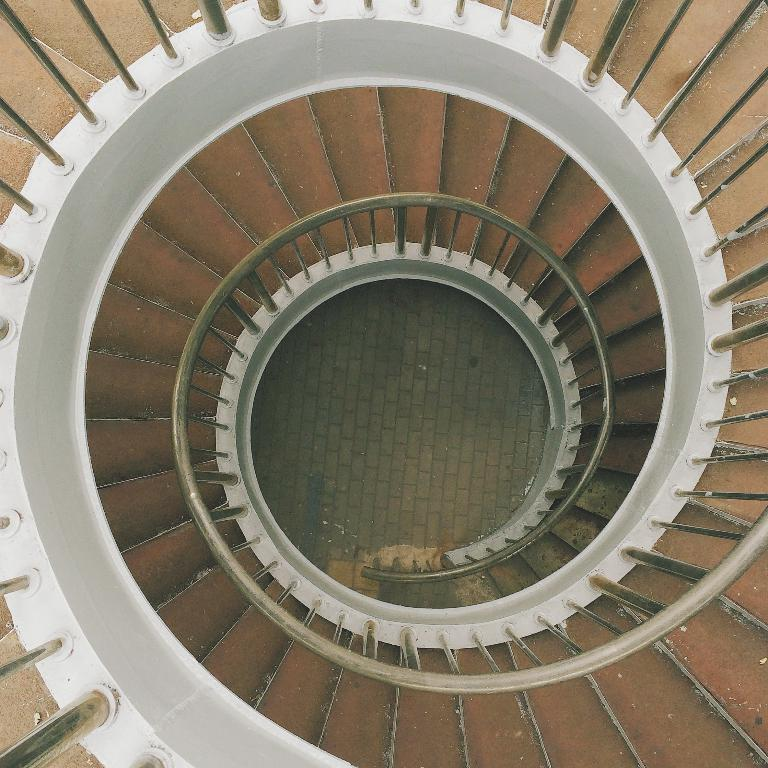What type of structure is present in the image? There are stairs in the image. Are there any additional features associated with the stairs? Yes, there are railings in the image. What type of lamp is present on the stairs in the image? There is no lamp present on the stairs in the image. 